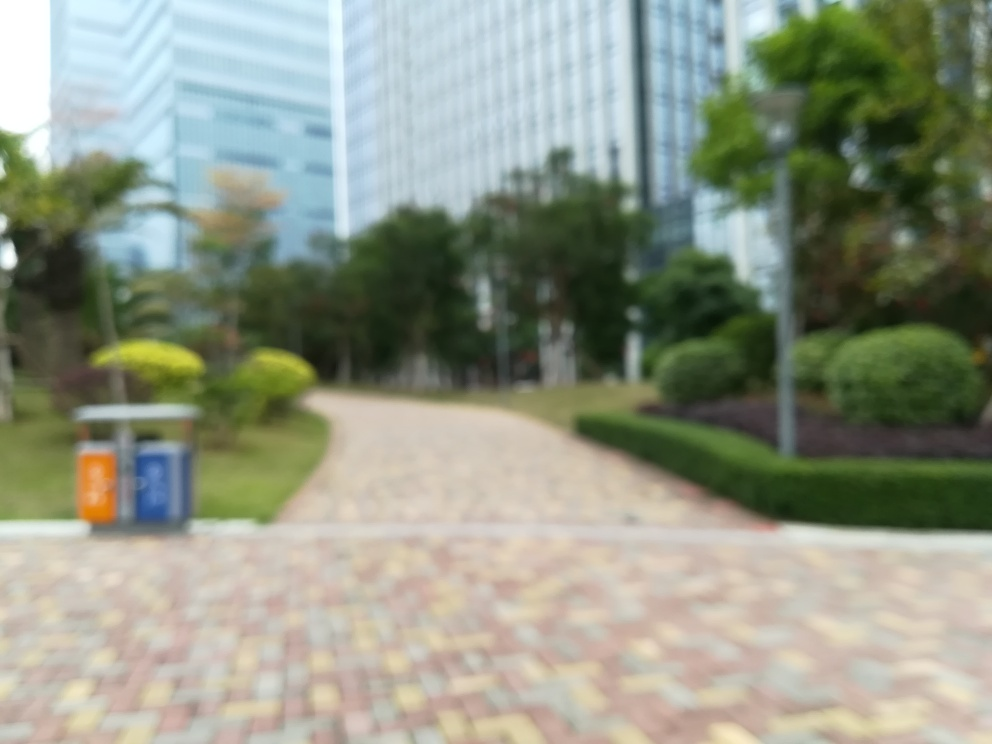Can you describe the setting of this image despite the blurriness? From what can be discerned, the image captures an outdoor scene possibly within an urban park or a landscaped area of a corporate or residential building. A path leads through the area, flanked by manicured greenery, and contemporary buildings can be seen in the background, suggesting a modern city environment. Judging by the elements in the picture, what time of day could it be? Although it's hard to tell due to the blurriness, the natural light does not seem to cast strong shadows, and the overall illumination is even, which could suggest an overcast day or a time close to either sunrise or sunset when the sunlight is diffused. 